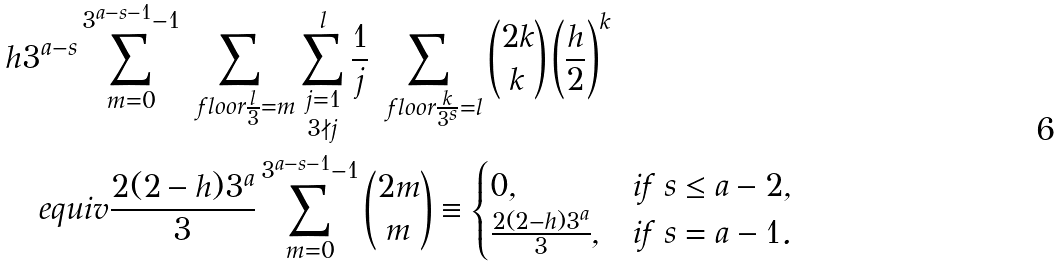Convert formula to latex. <formula><loc_0><loc_0><loc_500><loc_500>& h 3 ^ { a - s } \sum _ { m = 0 } ^ { 3 ^ { a - s - 1 } - 1 } \sum _ { \ f l o o r { \frac { l } { 3 } } = m } \sum _ { \substack { j = 1 \\ 3 \nmid j } } ^ { l } \frac { 1 } { j } \sum _ { \ f l o o r { \frac { k } { 3 ^ { s } } } = l } \binom { 2 k } { k } \left ( \frac { h } { 2 } \right ) ^ { k } \\ & \quad e q u i v \frac { 2 ( 2 - h ) 3 ^ { a } } { 3 } \sum _ { m = 0 } ^ { 3 ^ { a - s - 1 } - 1 } \binom { 2 m } { m } \equiv \begin{cases} 0 , & \text {if } s \leq a - 2 , \\ \frac { 2 ( 2 - h ) 3 ^ { a } } { 3 } , & \text {if} \ s = a - 1 . \end{cases}</formula> 